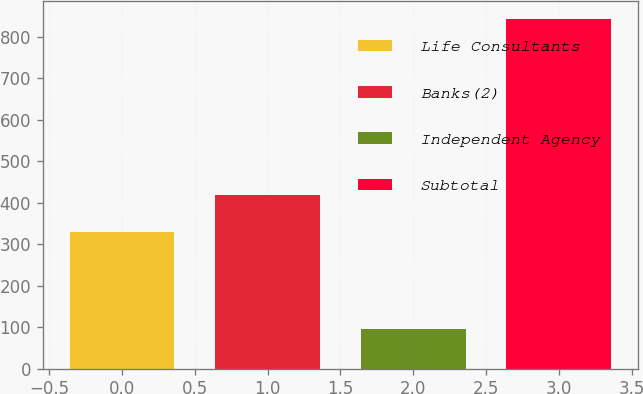<chart> <loc_0><loc_0><loc_500><loc_500><bar_chart><fcel>Life Consultants<fcel>Banks(2)<fcel>Independent Agency<fcel>Subtotal<nl><fcel>330<fcel>418<fcel>95<fcel>843<nl></chart> 